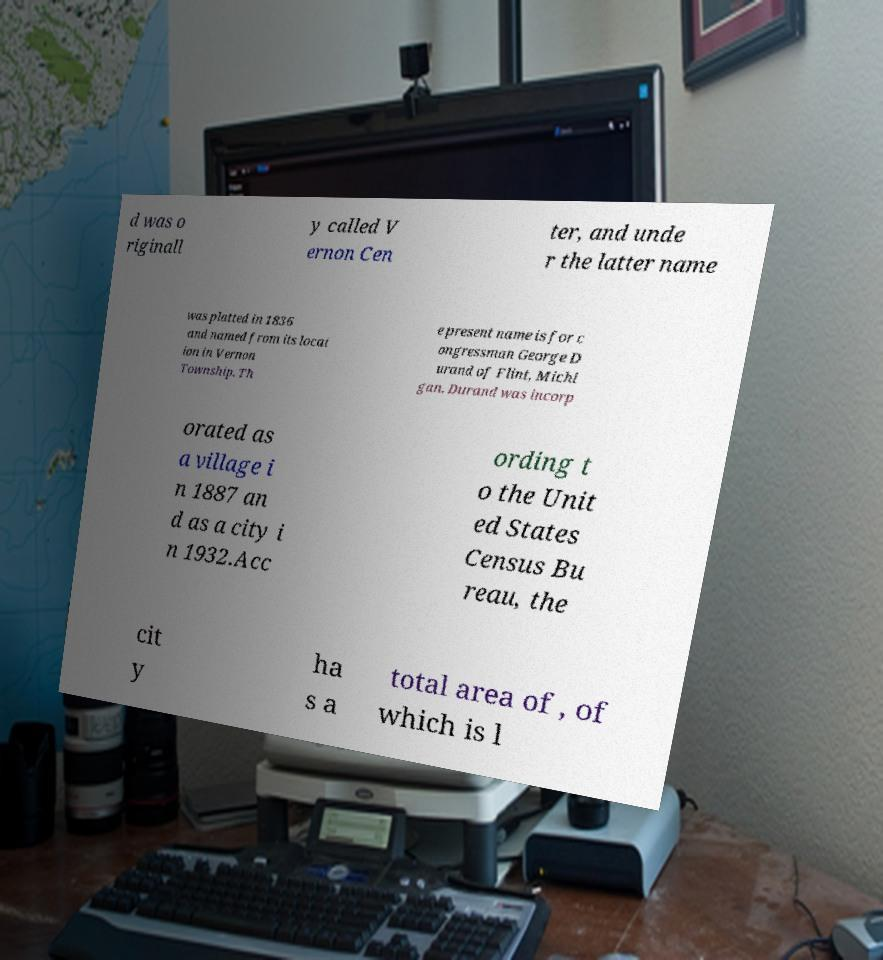Could you assist in decoding the text presented in this image and type it out clearly? d was o riginall y called V ernon Cen ter, and unde r the latter name was platted in 1836 and named from its locat ion in Vernon Township. Th e present name is for c ongressman George D urand of Flint, Michi gan. Durand was incorp orated as a village i n 1887 an d as a city i n 1932.Acc ording t o the Unit ed States Census Bu reau, the cit y ha s a total area of , of which is l 